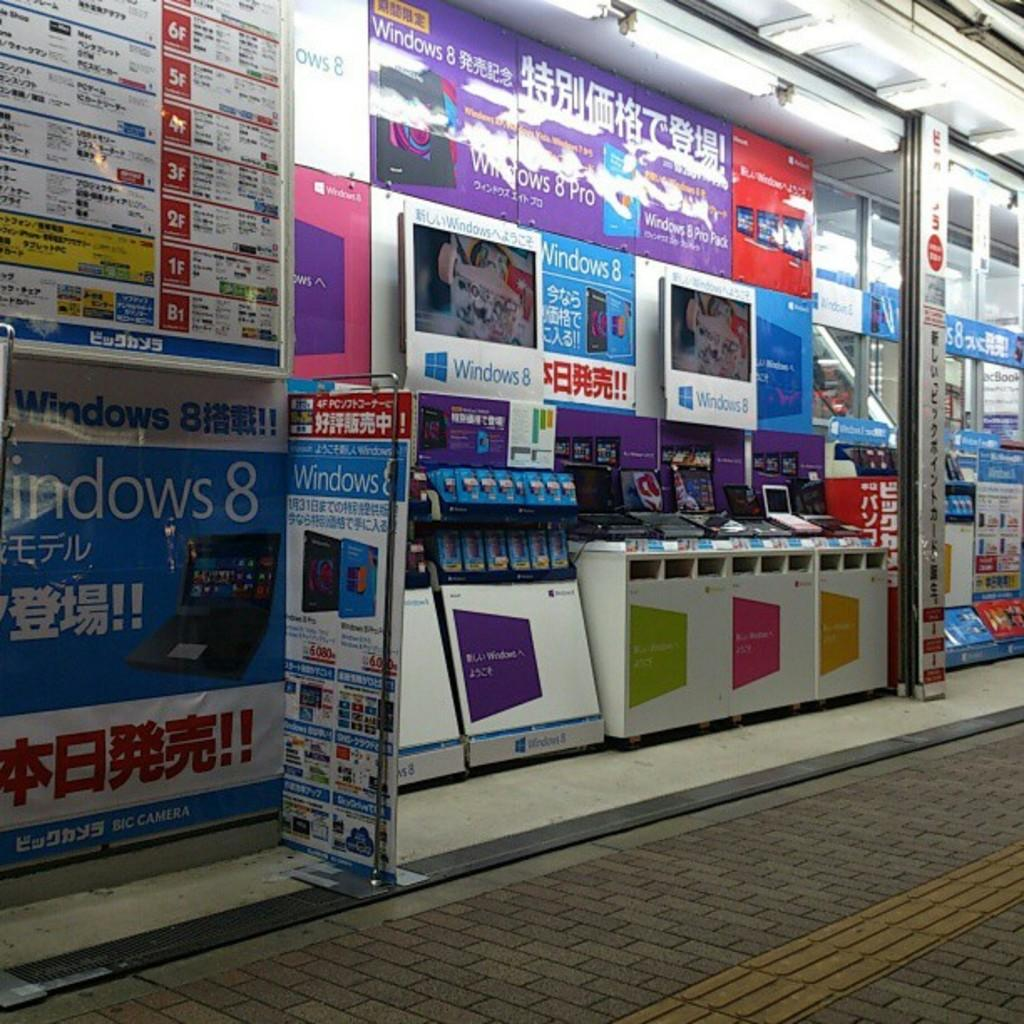<image>
Render a clear and concise summary of the photo. Booths for the Windows 8 computer are against the wall. 